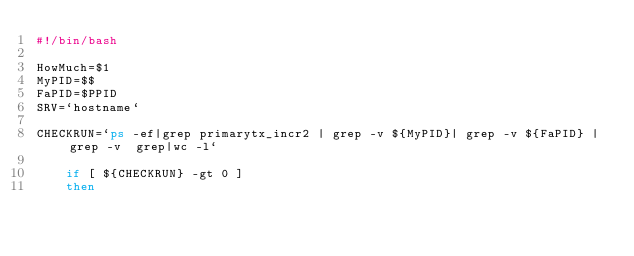<code> <loc_0><loc_0><loc_500><loc_500><_Bash_>#!/bin/bash

HowMuch=$1
MyPID=$$
FaPID=$PPID
SRV=`hostname`

CHECKRUN=`ps -ef|grep primarytx_incr2 | grep -v ${MyPID}| grep -v ${FaPID} |grep -v  grep|wc -l`

    if [ ${CHECKRUN} -gt 0 ]
    then</code> 